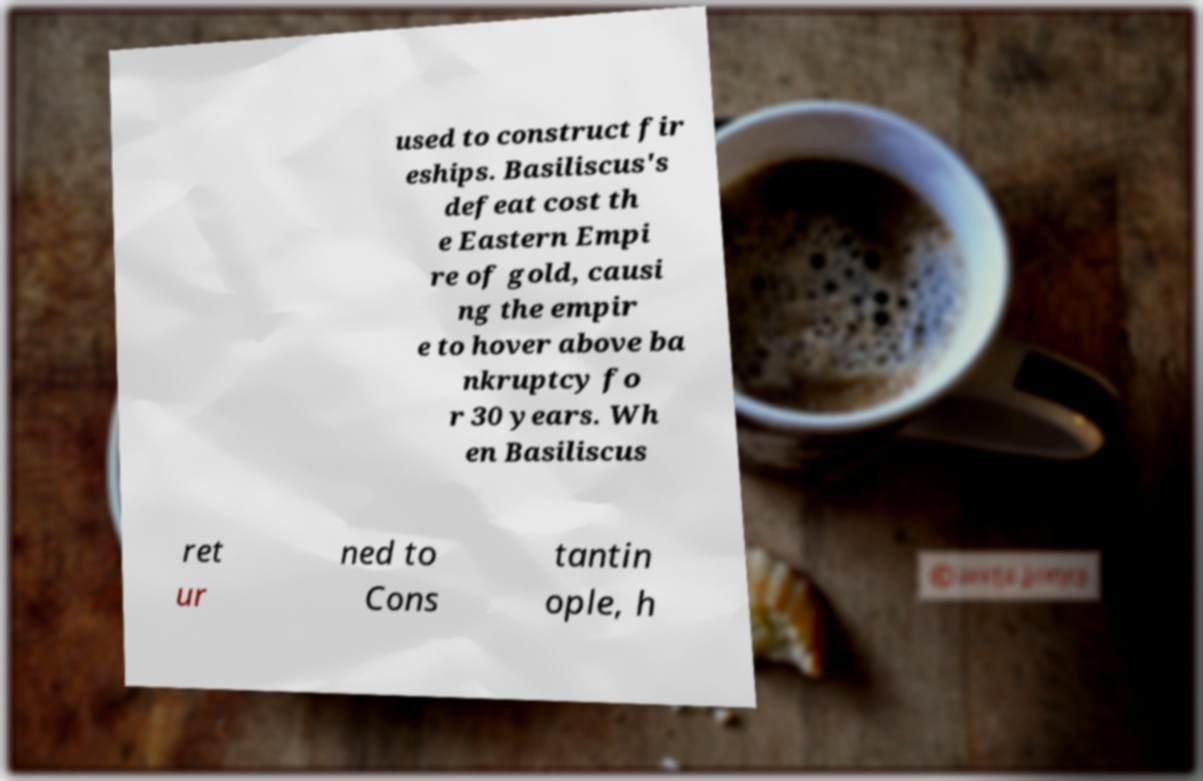I need the written content from this picture converted into text. Can you do that? used to construct fir eships. Basiliscus's defeat cost th e Eastern Empi re of gold, causi ng the empir e to hover above ba nkruptcy fo r 30 years. Wh en Basiliscus ret ur ned to Cons tantin ople, h 